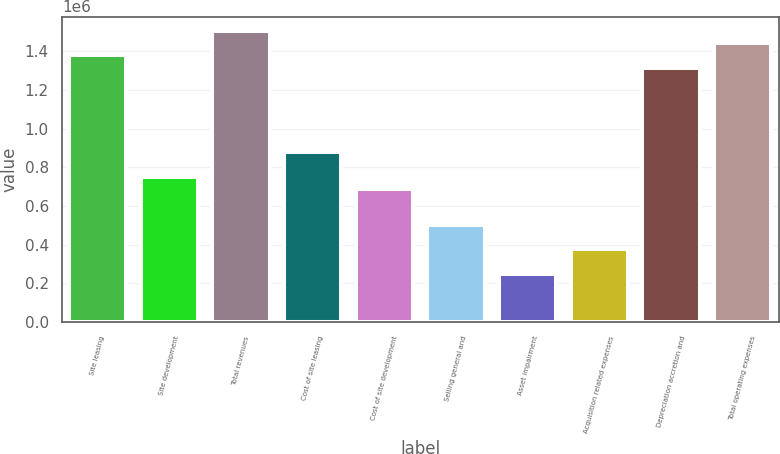<chart> <loc_0><loc_0><loc_500><loc_500><bar_chart><fcel>Site leasing<fcel>Site development<fcel>Total revenues<fcel>Cost of site leasing<fcel>Cost of site development<fcel>Selling general and<fcel>Asset impairment<fcel>Acquisition related expenses<fcel>Depreciation accretion and<fcel>Total operating expenses<nl><fcel>1.37856e+06<fcel>751942<fcel>1.50388e+06<fcel>877266<fcel>689281<fcel>501296<fcel>250649<fcel>375972<fcel>1.3159e+06<fcel>1.44122e+06<nl></chart> 